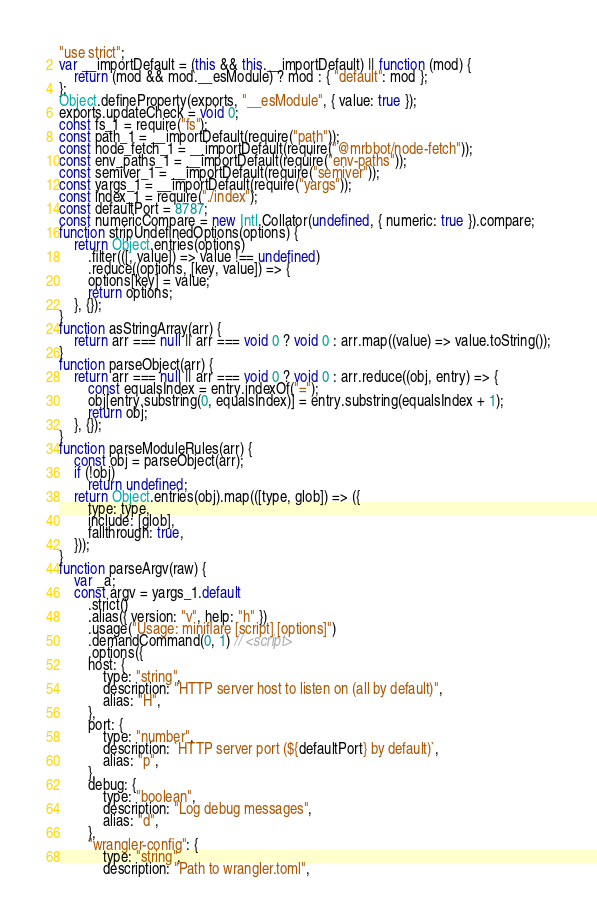Convert code to text. <code><loc_0><loc_0><loc_500><loc_500><_JavaScript_>"use strict";
var __importDefault = (this && this.__importDefault) || function (mod) {
    return (mod && mod.__esModule) ? mod : { "default": mod };
};
Object.defineProperty(exports, "__esModule", { value: true });
exports.updateCheck = void 0;
const fs_1 = require("fs");
const path_1 = __importDefault(require("path"));
const node_fetch_1 = __importDefault(require("@mrbbot/node-fetch"));
const env_paths_1 = __importDefault(require("env-paths"));
const semiver_1 = __importDefault(require("semiver"));
const yargs_1 = __importDefault(require("yargs"));
const index_1 = require("./index");
const defaultPort = 8787;
const numericCompare = new Intl.Collator(undefined, { numeric: true }).compare;
function stripUndefinedOptions(options) {
    return Object.entries(options)
        .filter(([, value]) => value !== undefined)
        .reduce((options, [key, value]) => {
        options[key] = value;
        return options;
    }, {});
}
function asStringArray(arr) {
    return arr === null || arr === void 0 ? void 0 : arr.map((value) => value.toString());
}
function parseObject(arr) {
    return arr === null || arr === void 0 ? void 0 : arr.reduce((obj, entry) => {
        const equalsIndex = entry.indexOf("=");
        obj[entry.substring(0, equalsIndex)] = entry.substring(equalsIndex + 1);
        return obj;
    }, {});
}
function parseModuleRules(arr) {
    const obj = parseObject(arr);
    if (!obj)
        return undefined;
    return Object.entries(obj).map(([type, glob]) => ({
        type: type,
        include: [glob],
        fallthrough: true,
    }));
}
function parseArgv(raw) {
    var _a;
    const argv = yargs_1.default
        .strict()
        .alias({ version: "v", help: "h" })
        .usage("Usage: miniflare [script] [options]")
        .demandCommand(0, 1) // <script>
        .options({
        host: {
            type: "string",
            description: "HTTP server host to listen on (all by default)",
            alias: "H",
        },
        port: {
            type: "number",
            description: `HTTP server port (${defaultPort} by default)`,
            alias: "p",
        },
        debug: {
            type: "boolean",
            description: "Log debug messages",
            alias: "d",
        },
        "wrangler-config": {
            type: "string",
            description: "Path to wrangler.toml",</code> 